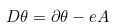<formula> <loc_0><loc_0><loc_500><loc_500>D \theta = \partial \theta - e A</formula> 